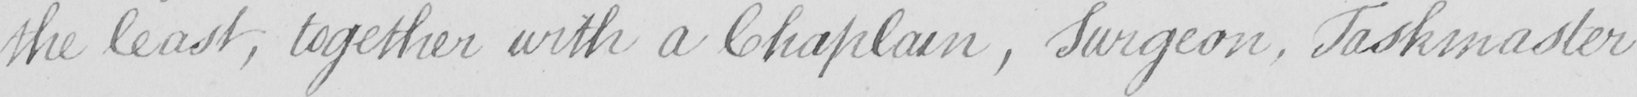Please transcribe the handwritten text in this image. the least , together with a Chaplain , Surgeon , Taskmaster 